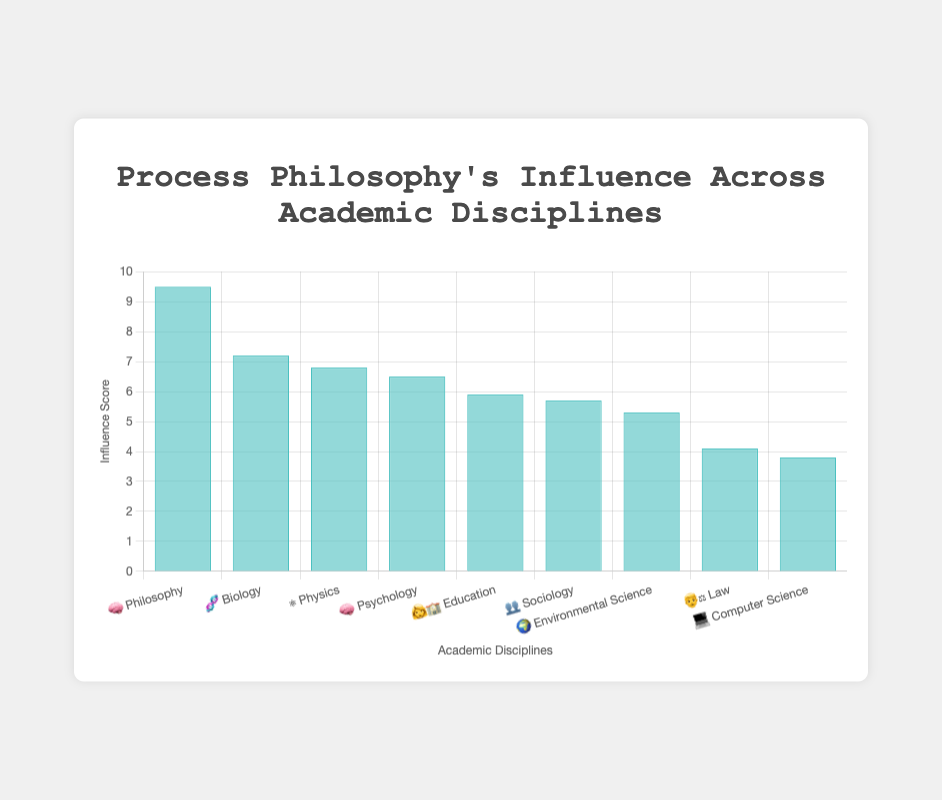Which academic discipline shows the highest influence of process philosophy? To determine which discipline has the highest influence, look for the bar with the greatest height. The title of the bar will tell you the discipline. Here, 🧠 Philosophy has the highest value at 9.5.
Answer: Philosophy Which academic discipline has the lowest influence of process philosophy? Identify the shortest bar on the chart, which corresponds to the lowest influence. Look at the name next to it. Here, 💻 Computer Science has the lowest value at 3.8.
Answer: Computer Science What is the influence score of process philosophy on the discipline of Biology? Locate the bar labeled 🧬 Biology and read the height/value of this bar. The influence is indicated as 7.2.
Answer: 7.2 Which discipline has a higher influence score, Psychology or Education? Compare the bars for 🧠 Psychology and 👩‍🏫 Education. Psychology has an influence of 6.5 while Education has 5.9, making Psychology's influence score higher.
Answer: Psychology How much more influence does process philosophy have in Philosophy than in Law? Subtract the influence score of 👨‍⚖️ Law (4.1) from that of 🧠 Philosophy (9.5). The difference is 9.5 - 4.1 = 5.4.
Answer: 5.4 What's the average influence score of process philosophy across all disciplines? Add all influence scores (9.5+7.2+6.8+6.5+5.9+5.7+5.3+4.1+3.8) and divide by the number of disciplines (9). The sum is 54.8, and the average is 54.8 / 9 = 6.09.
Answer: 6.09 Which two disciplines have the closest influence scores? Look for bars with similar heights. 🧠 Psychology (6.5) and ⚛️ Physics (6.8) have very close influence scores, differing by just 0.3.
Answer: Psychology and Physics Place the disciplines in order from highest to lowest influence. Arrange the bars in descending order based on their height: Philosophy (9.5), Biology (7.2), Physics (6.8), Psychology (6.5), Education (5.9), Sociology (5.7), Environmental Science (5.3), Law (4.1), Computer Science (3.8).
Answer: Philosophy, Biology, Physics, Psychology, Education, Sociology, Environmental Science, Law, Computer Science What is the total influence score of process philosophy in the social sciences (Sociology, Psychology, Law)? Add the influence scores of 🧠 Psychology (6.5), 👥 Sociology (5.7), and 👨‍⚖️ Law (4.1). The total is 6.5 + 5.7 + 4.1 = 16.3.
Answer: 16.3 